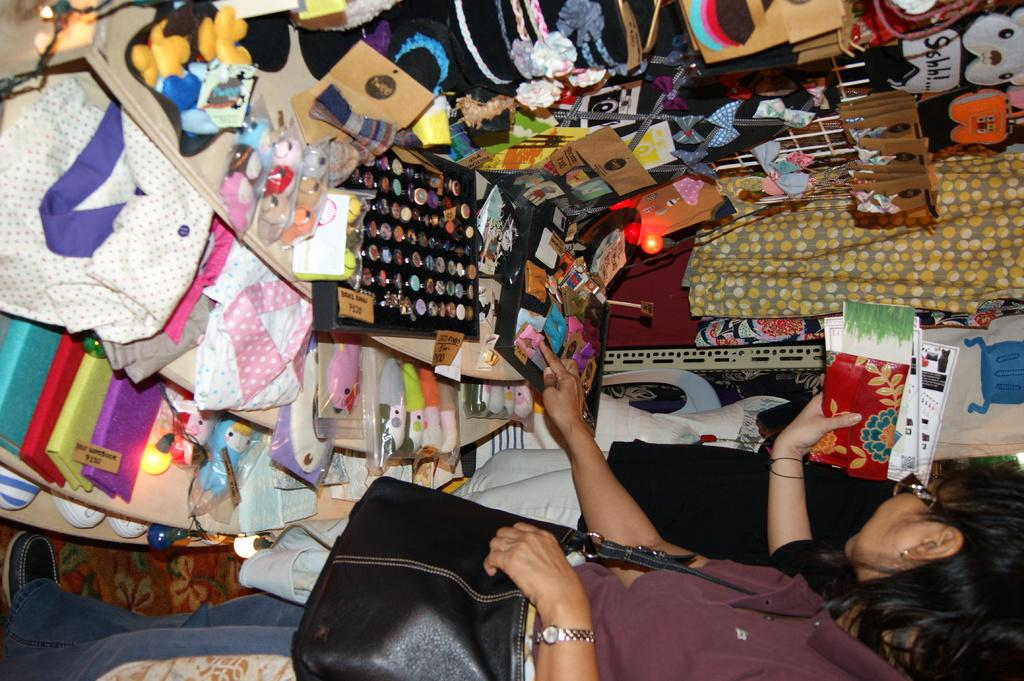How many people are in the image? There are two people standing in the image. What is the woman carrying? The woman is carrying a bag. What type of items can be seen in the image related to daily life? Clothes, toys, books, and footwear are visible in the image. Can you describe the light source in the image? A light source is present in the image. What other objects can be seen in the image? There are other objects in the image. What type of ice can be seen melting on the ground in the image? There is no ice present in the image; it does not show any melting ice on the ground. 